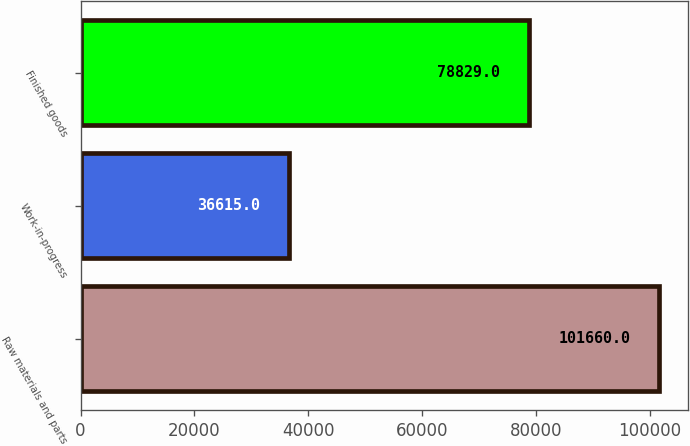Convert chart to OTSL. <chart><loc_0><loc_0><loc_500><loc_500><bar_chart><fcel>Raw materials and parts<fcel>Work-in-progress<fcel>Finished goods<nl><fcel>101660<fcel>36615<fcel>78829<nl></chart> 